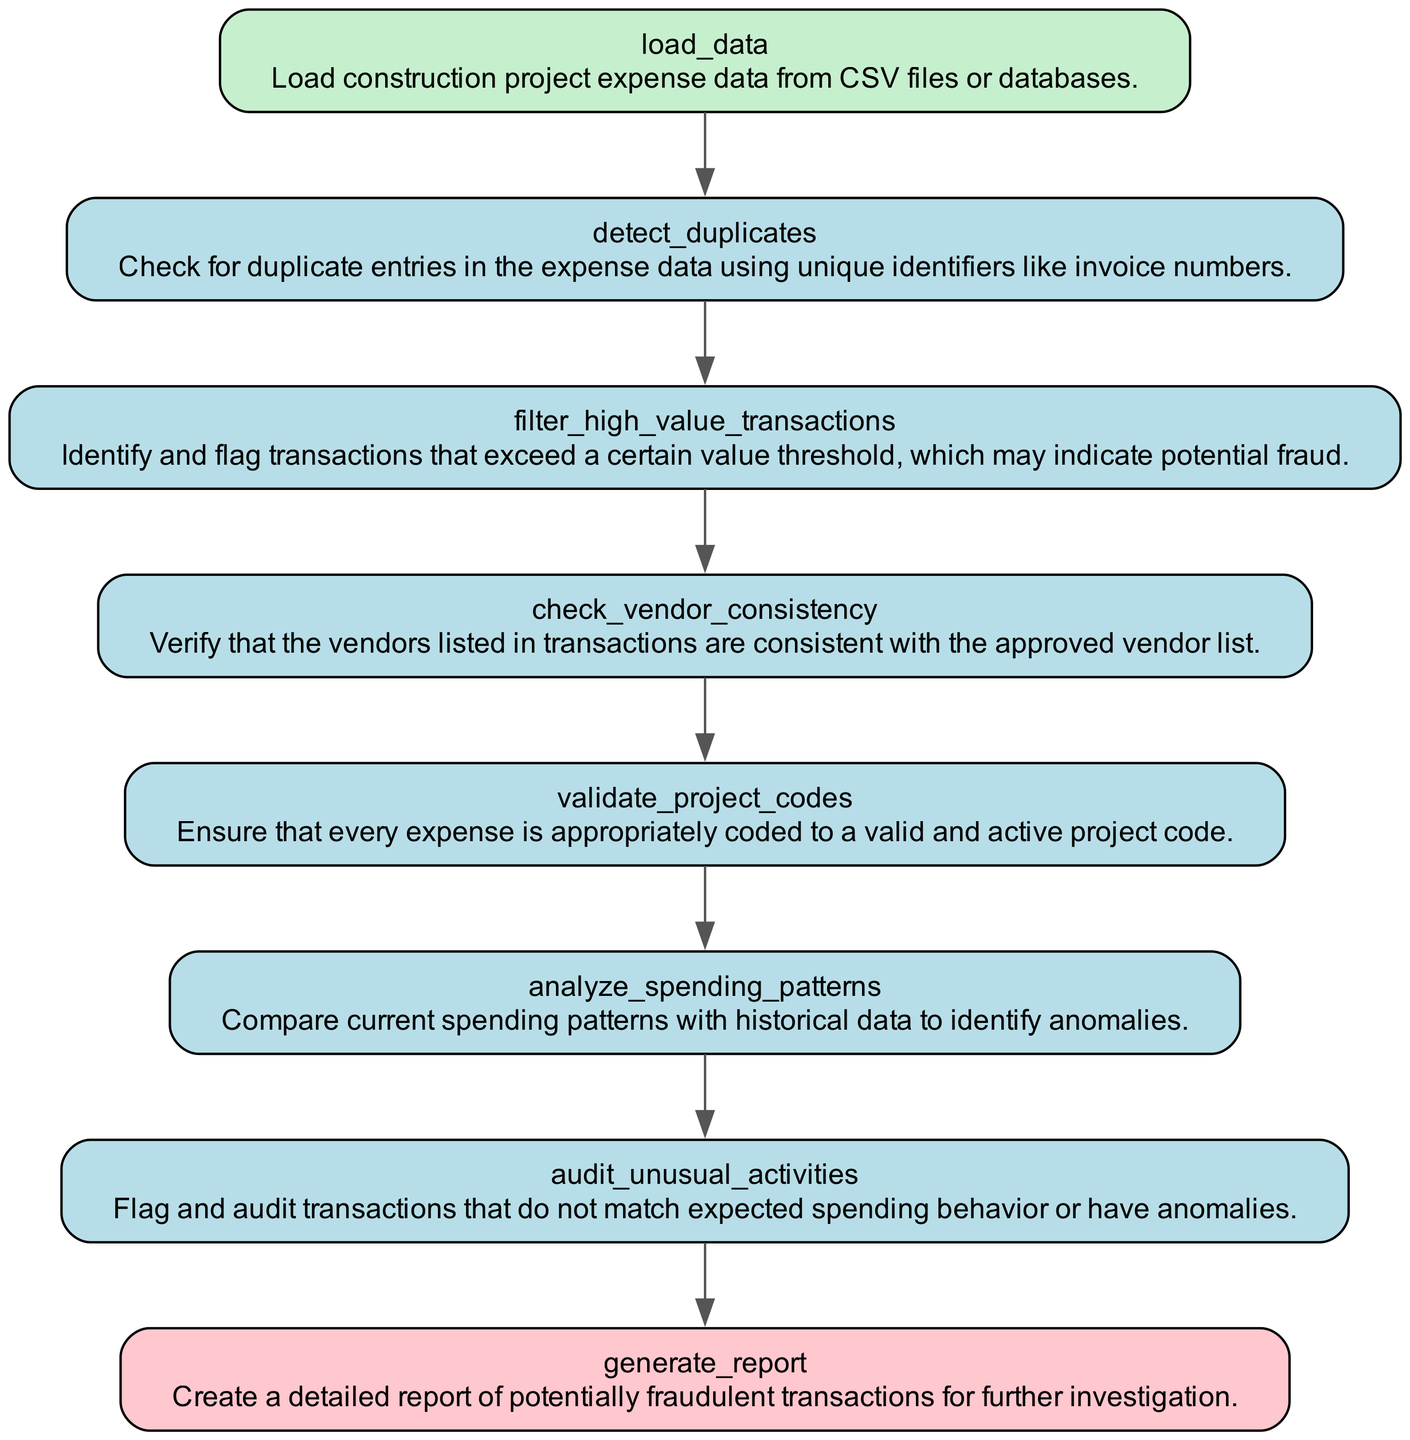what is the first step in the flowchart? The first step in the flowchart is the "load_data" process. This step is where construction project expense data is loaded from CSV files or databases.
Answer: load_data how many process nodes are in the diagram? There are six process nodes in the diagram: "detect_duplicates," "filter_high_value_transactions," "check_vendor_consistency," "validate_project_codes," "analyze_spending_patterns," and "audit_unusual_activities."
Answer: six what is the purpose of the 'generate_report' node? The purpose of the 'generate_report' node is to create a detailed report of potentially fraudulent transactions for further investigation.
Answer: create a detailed report which node checks for duplicate entries in the expense data? The node that checks for duplicate entries in the expense data is "detect_duplicates." This process utilizes unique identifiers like invoice numbers for its operation.
Answer: detect_duplicates what is the relationship between 'audit_unusual_activities' and 'generate_report'? The relationship between 'audit_unusual_activities' and 'generate_report' is that 'audit_unusual_activities' is the process that identifies transactions for further review, leading directly to the generation of the report.
Answer: direct connection which node flags high-value transactions? The node that flags high-value transactions is "filter_high_value_transactions." It identifies transactions that exceed a certain value threshold, indicating potential fraud.
Answer: filter_high_value_transactions how many input nodes are present in this flowchart? There is one input node in this flowchart: "load_data." This is the initial step where the data is introduced into the process.
Answer: one what does the 'validate_project_codes' process ensure? The 'validate_project_codes' process ensures that every expense is appropriately coded to a valid and active project code, preventing incorrect expense tracking.
Answer: valid and active project code which process follows 'check_vendor_consistency'? The process that follows 'check_vendor_consistency' is 'validate_project_codes.' This flow indicates that checking vendor consistency comes before validating project codes.
Answer: validate_project_codes 